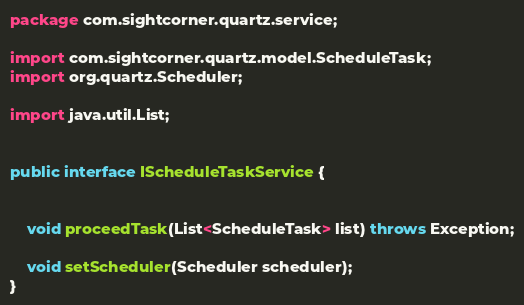Convert code to text. <code><loc_0><loc_0><loc_500><loc_500><_Java_>package com.sightcorner.quartz.service;

import com.sightcorner.quartz.model.ScheduleTask;
import org.quartz.Scheduler;

import java.util.List;


public interface IScheduleTaskService {


	void proceedTask(List<ScheduleTask> list) throws Exception;

	void setScheduler(Scheduler scheduler);
}
</code> 